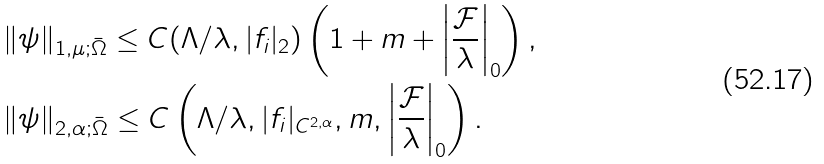Convert formula to latex. <formula><loc_0><loc_0><loc_500><loc_500>& \| \psi \| _ { 1 , \mu ; \bar { \Omega } } \leq C ( \Lambda / \lambda , | f _ { i } | _ { 2 } ) \left ( 1 + m + \left | \frac { \mathcal { F } } { \lambda } \right | _ { 0 } \right ) , \\ & \| \psi \| _ { 2 , \alpha ; \bar { \Omega } } \leq C \left ( \Lambda / \lambda , | f _ { i } | _ { C ^ { 2 , \alpha } } , m , \left | \frac { \mathcal { F } } { \lambda } \right | _ { 0 } \right ) .</formula> 